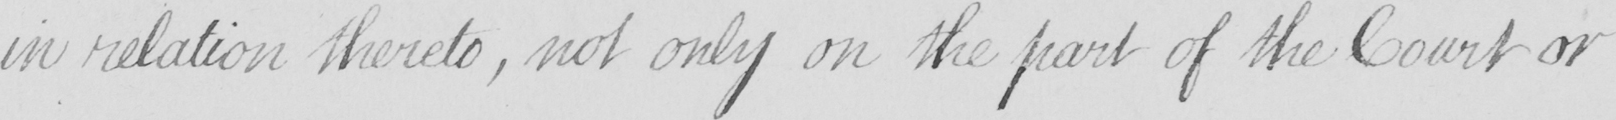Can you read and transcribe this handwriting? in relation thereto , not only on the part of the Court or 